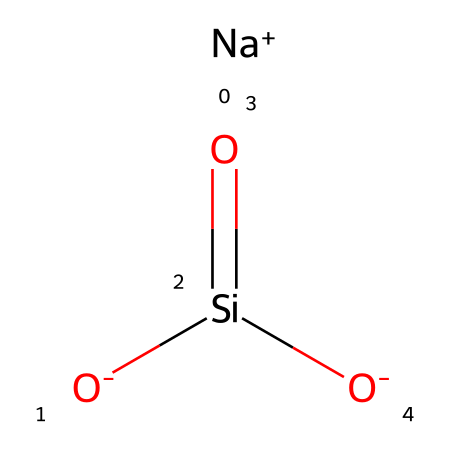What is the primary metal ion present in this structure? The SMILES shows [Na+], indicating that sodium is present as the cation.
Answer: sodium How many silicon atoms are in the structure? The structure has one silicon atom, indicated by the "Si" in the SMILES representation.
Answer: one What type of bond is predominantly present between silicon and oxygen? The presence of oxygen as double-bonded to silicon in Si(=O) indicates a covalent bond character due to shared electron pairs.
Answer: covalent What is the overall charge of the molecule? The sodium ion contributes a positive charge (+1) and each oxygen contributes a negative charge (-2 in total), resulting in a neutral molecule overall.
Answer: neutral Identify the functional group associated with this chemical that strengthens glass. The Si-O (siloxane) structure is responsible for the glass-strengthening properties, as silicate networks enhance structural integrity.
Answer: siloxane Which elements are present in this chemical structure? The SMILES indicates the presence of sodium, silicon, and oxygen based on the atoms represented.
Answer: sodium, silicon, oxygen 